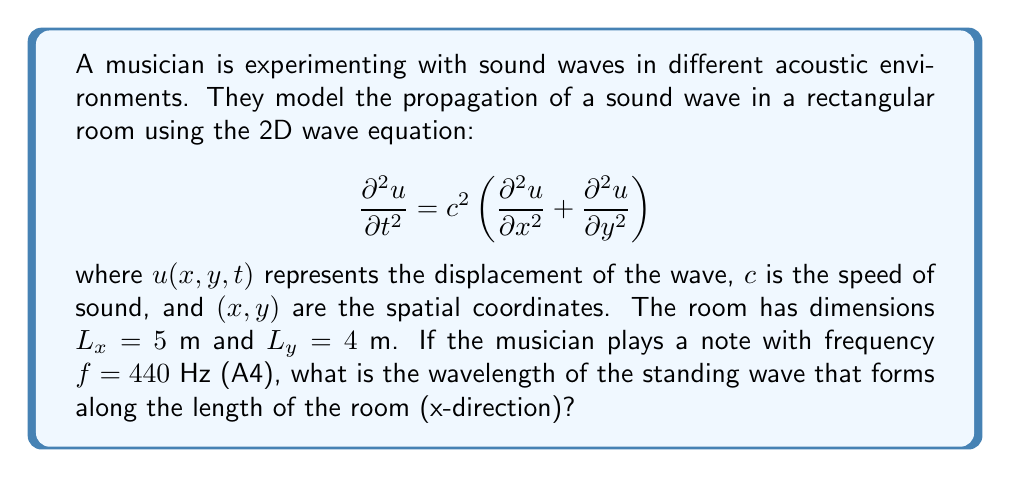What is the answer to this math problem? Let's approach this step-by-step:

1) For a standing wave in the x-direction, we need to consider the boundary conditions:
   $$u(0,y,t) = u(L_x,y,t) = 0$$

2) The general solution for a standing wave in the x-direction is:
   $$u(x,t) = A \sin(k_x x) \cos(\omega t)$$
   where $k_x$ is the wave number and $\omega = 2\pi f$ is the angular frequency.

3) To satisfy the boundary conditions, we must have:
   $$k_x = \frac{n\pi}{L_x}$$
   where $n$ is a positive integer.

4) The wavelength $\lambda$ is related to the wave number by:
   $$k_x = \frac{2\pi}{\lambda}$$

5) Equating these two expressions for $k_x$:
   $$\frac{2\pi}{\lambda} = \frac{n\pi}{L_x}$$

6) Solving for $\lambda$:
   $$\lambda = \frac{2L_x}{n}$$

7) We need to determine which $n$ corresponds to the given frequency. We can use the wave equation:
   $$c = f\lambda$$

8) Substituting our expression for $\lambda$:
   $$c = f \cdot \frac{2L_x}{n}$$

9) Solving for $n$:
   $$n = \frac{2fL_x}{c}$$

10) Using $c = 343$ m/s (speed of sound in air at room temperature), $f = 440$ Hz, and $L_x = 5$ m:
    $$n = \frac{2 \cdot 440 \cdot 5}{343} \approx 12.83$$

11) Since $n$ must be an integer, we round to the nearest integer: $n = 13$

12) Now we can calculate the wavelength:
    $$\lambda = \frac{2L_x}{n} = \frac{2 \cdot 5}{13} \approx 0.769$$ m
Answer: $\lambda \approx 0.769$ m 